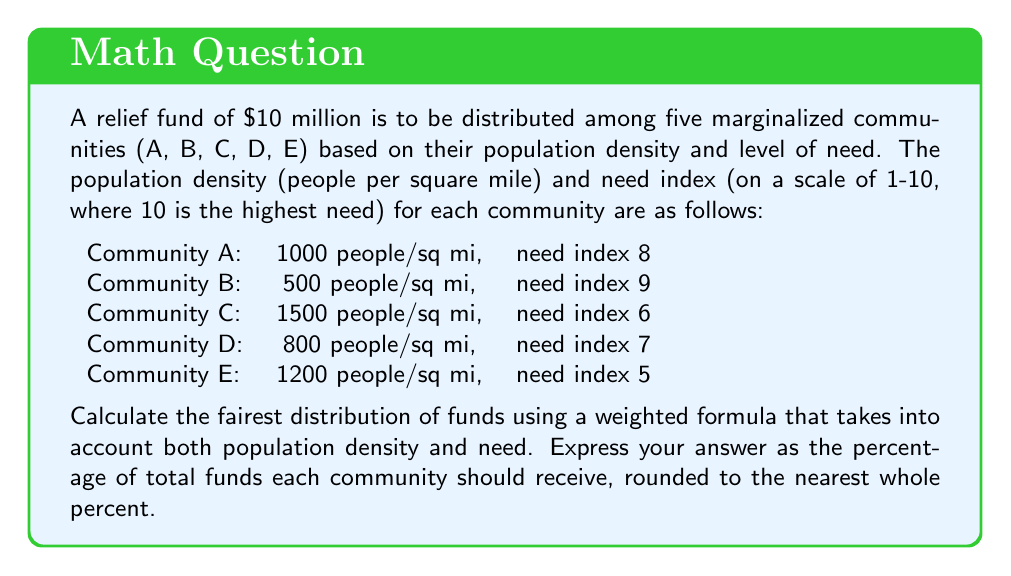Solve this math problem. To calculate the fairest distribution of funds, we'll use a weighted formula that considers both population density and need. Here's the step-by-step process:

1. Calculate a combined score for each community:
   Let's use the formula: $\text{Score} = \text{Population Density} \times \text{Need Index}$

   Community A: $1000 \times 8 = 8000$
   Community B: $500 \times 9 = 4500$
   Community C: $1500 \times 6 = 9000$
   Community D: $800 \times 7 = 5600$
   Community E: $1200 \times 5 = 6000$

2. Calculate the total score:
   $\text{Total Score} = 8000 + 4500 + 9000 + 5600 + 6000 = 33100$

3. Calculate the percentage for each community:
   $\text{Percentage} = \frac{\text{Community Score}}{\text{Total Score}} \times 100\%$

   Community A: $\frac{8000}{33100} \times 100\% \approx 24.17\%$
   Community B: $\frac{4500}{33100} \times 100\% \approx 13.60\%$
   Community C: $\frac{9000}{33100} \times 100\% \approx 27.19\%$
   Community D: $\frac{5600}{33100} \times 100\% \approx 16.92\%$
   Community E: $\frac{6000}{33100} \times 100\% \approx 18.13\%$

4. Round to the nearest whole percent:
   Community A: 24%
   Community B: 14%
   Community C: 27%
   Community D: 17%
   Community E: 18%

This distribution ensures that communities with higher population densities and greater needs receive a larger share of the funds, while still providing support to all communities based on their relative scores.
Answer: The fairest distribution of funds, rounded to the nearest whole percent:
Community A: 24%
Community B: 14%
Community C: 27%
Community D: 17%
Community E: 18% 